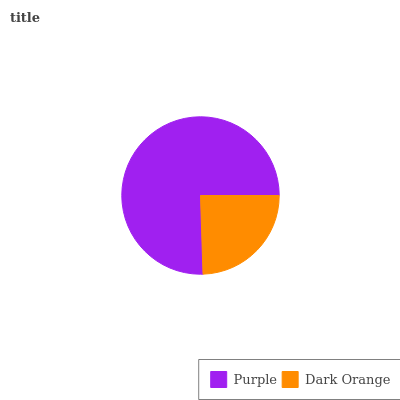Is Dark Orange the minimum?
Answer yes or no. Yes. Is Purple the maximum?
Answer yes or no. Yes. Is Dark Orange the maximum?
Answer yes or no. No. Is Purple greater than Dark Orange?
Answer yes or no. Yes. Is Dark Orange less than Purple?
Answer yes or no. Yes. Is Dark Orange greater than Purple?
Answer yes or no. No. Is Purple less than Dark Orange?
Answer yes or no. No. Is Purple the high median?
Answer yes or no. Yes. Is Dark Orange the low median?
Answer yes or no. Yes. Is Dark Orange the high median?
Answer yes or no. No. Is Purple the low median?
Answer yes or no. No. 